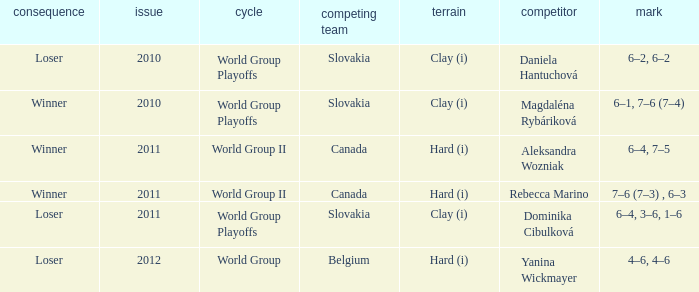What was the score when the opponent was Dominika Cibulková? 6–4, 3–6, 1–6. 